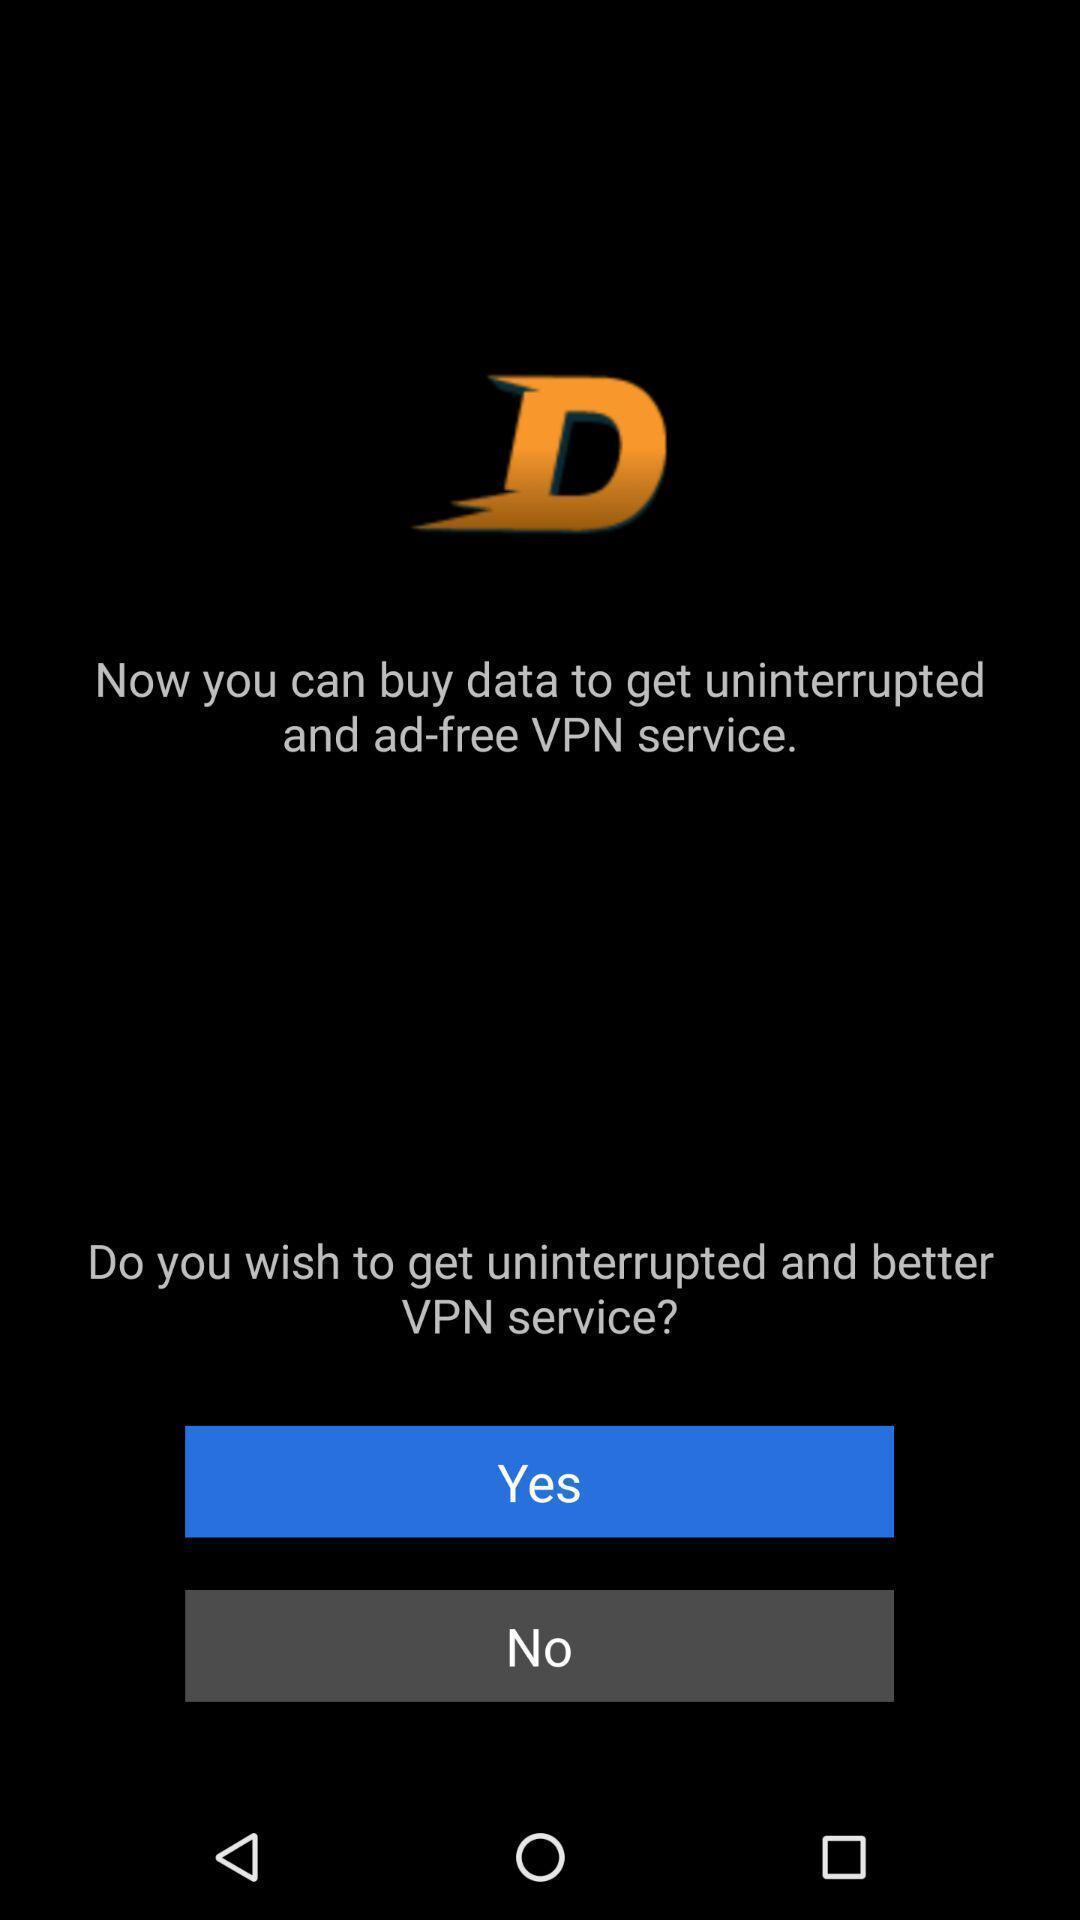Explain the elements present in this screenshot. Vpn service turn on option. 